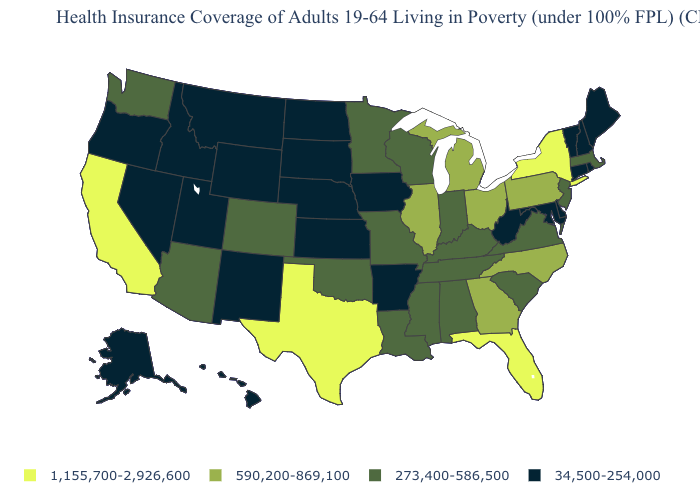What is the value of Indiana?
Short answer required. 273,400-586,500. Name the states that have a value in the range 1,155,700-2,926,600?
Be succinct. California, Florida, New York, Texas. Among the states that border North Carolina , does South Carolina have the lowest value?
Be succinct. Yes. Does Alaska have the lowest value in the USA?
Write a very short answer. Yes. Name the states that have a value in the range 1,155,700-2,926,600?
Answer briefly. California, Florida, New York, Texas. Does Wyoming have the highest value in the USA?
Be succinct. No. Does Iowa have the highest value in the MidWest?
Concise answer only. No. What is the highest value in the South ?
Quick response, please. 1,155,700-2,926,600. Does the map have missing data?
Short answer required. No. Which states have the lowest value in the Northeast?
Concise answer only. Connecticut, Maine, New Hampshire, Rhode Island, Vermont. Does Texas have the highest value in the South?
Write a very short answer. Yes. Does the first symbol in the legend represent the smallest category?
Be succinct. No. Among the states that border New Hampshire , which have the lowest value?
Be succinct. Maine, Vermont. What is the value of New Hampshire?
Quick response, please. 34,500-254,000. Name the states that have a value in the range 1,155,700-2,926,600?
Concise answer only. California, Florida, New York, Texas. 